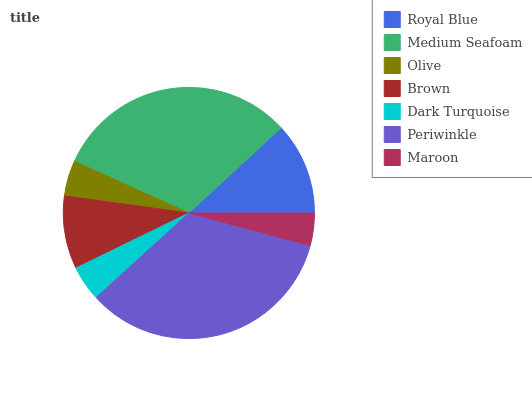Is Maroon the minimum?
Answer yes or no. Yes. Is Periwinkle the maximum?
Answer yes or no. Yes. Is Medium Seafoam the minimum?
Answer yes or no. No. Is Medium Seafoam the maximum?
Answer yes or no. No. Is Medium Seafoam greater than Royal Blue?
Answer yes or no. Yes. Is Royal Blue less than Medium Seafoam?
Answer yes or no. Yes. Is Royal Blue greater than Medium Seafoam?
Answer yes or no. No. Is Medium Seafoam less than Royal Blue?
Answer yes or no. No. Is Brown the high median?
Answer yes or no. Yes. Is Brown the low median?
Answer yes or no. Yes. Is Medium Seafoam the high median?
Answer yes or no. No. Is Periwinkle the low median?
Answer yes or no. No. 